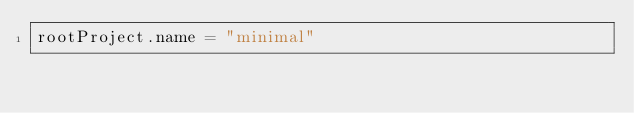Convert code to text. <code><loc_0><loc_0><loc_500><loc_500><_Kotlin_>rootProject.name = "minimal"
</code> 